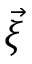Convert formula to latex. <formula><loc_0><loc_0><loc_500><loc_500>\vec { \xi }</formula> 